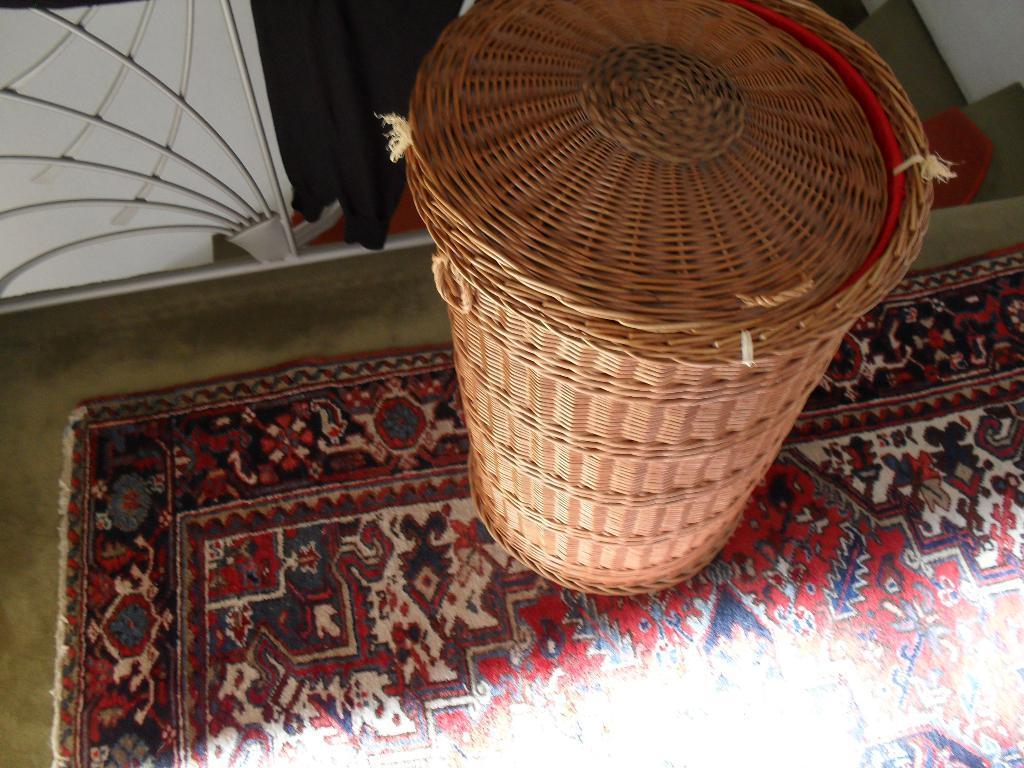In one or two sentences, can you explain what this image depicts? Here in this picture we can see a bin present on the floor over there and we can also see the floor is covered with carpet over there. 